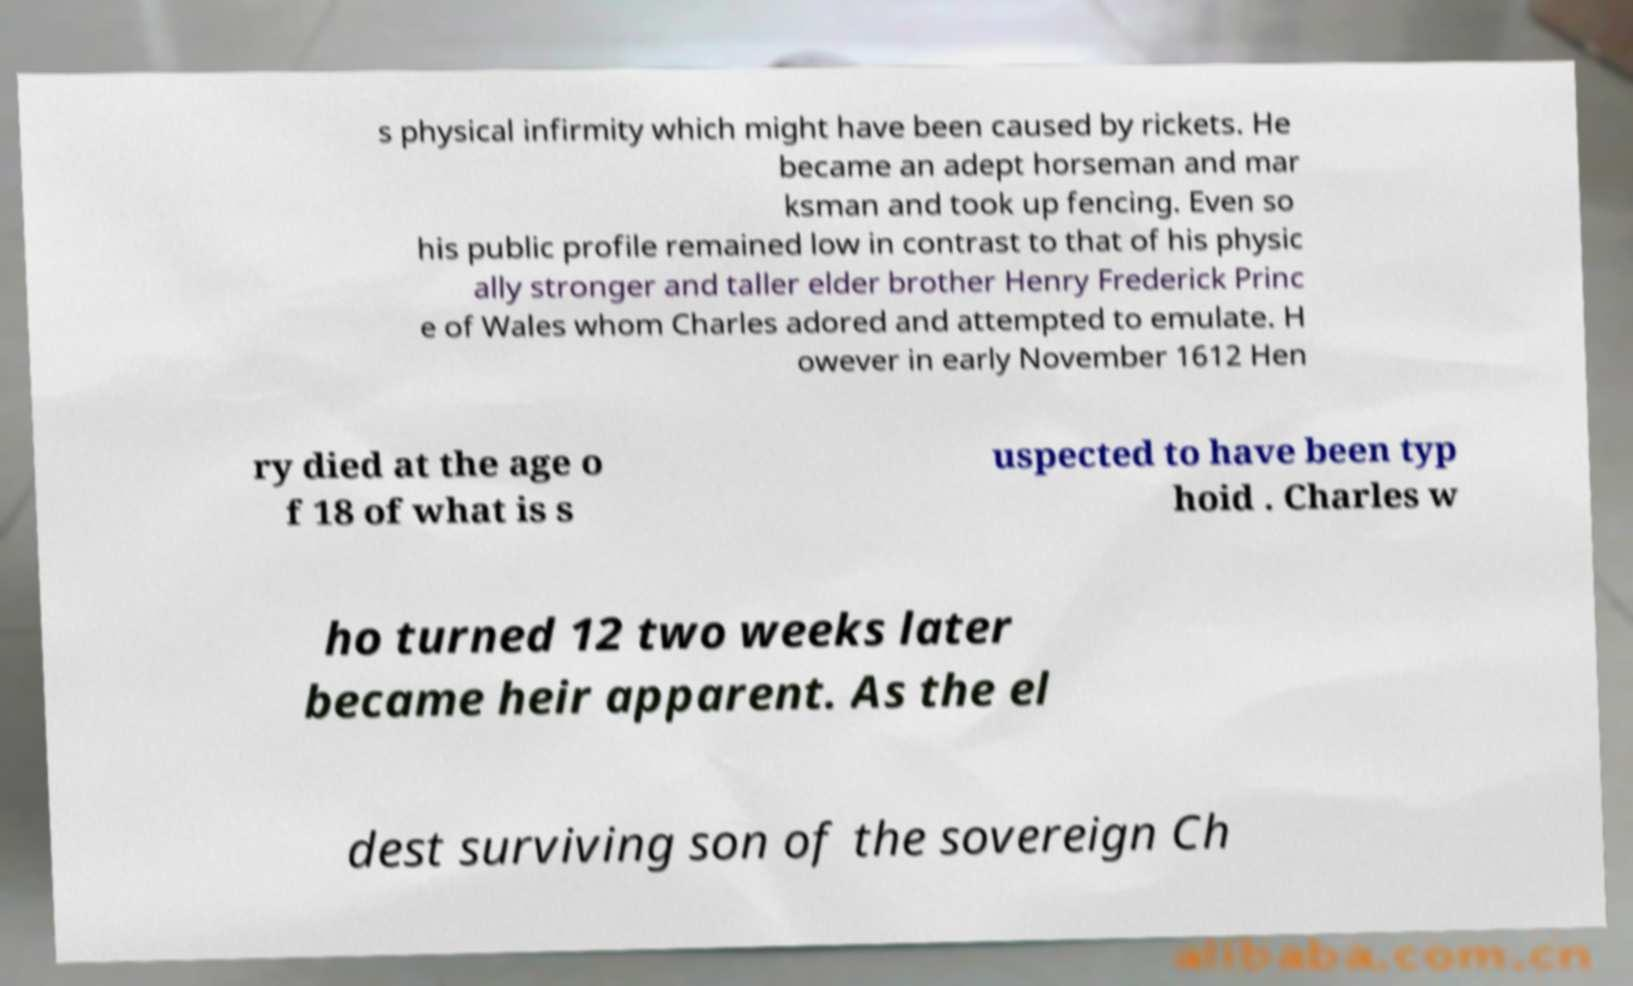Please read and relay the text visible in this image. What does it say? s physical infirmity which might have been caused by rickets. He became an adept horseman and mar ksman and took up fencing. Even so his public profile remained low in contrast to that of his physic ally stronger and taller elder brother Henry Frederick Princ e of Wales whom Charles adored and attempted to emulate. H owever in early November 1612 Hen ry died at the age o f 18 of what is s uspected to have been typ hoid . Charles w ho turned 12 two weeks later became heir apparent. As the el dest surviving son of the sovereign Ch 